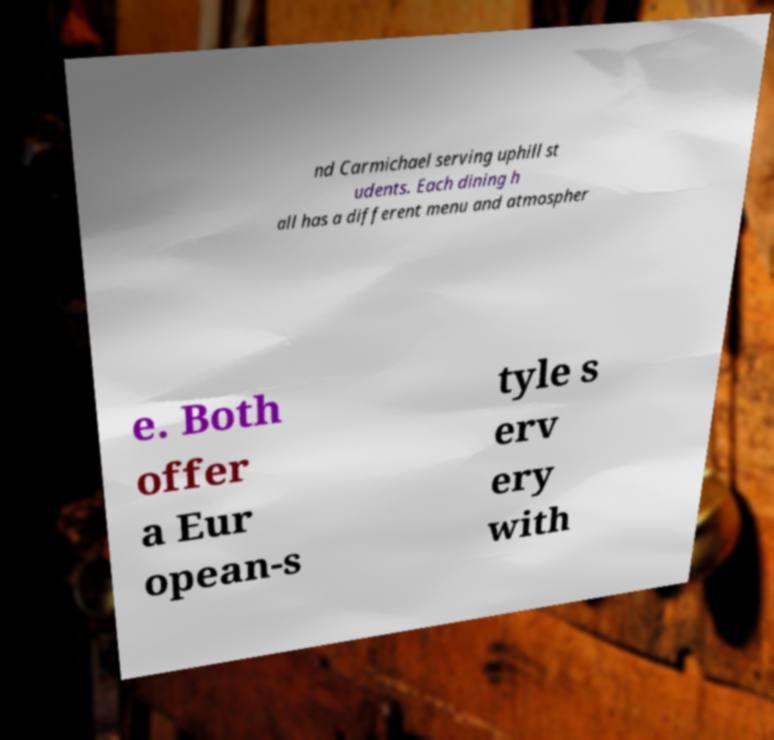Please identify and transcribe the text found in this image. nd Carmichael serving uphill st udents. Each dining h all has a different menu and atmospher e. Both offer a Eur opean-s tyle s erv ery with 